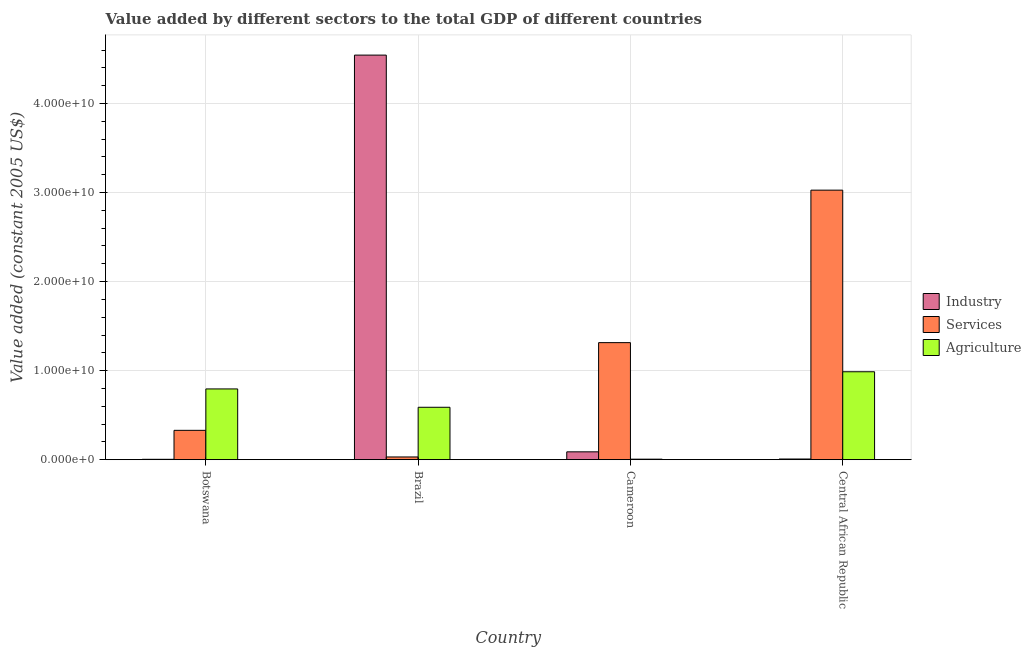Are the number of bars per tick equal to the number of legend labels?
Your response must be concise. Yes. Are the number of bars on each tick of the X-axis equal?
Provide a succinct answer. Yes. How many bars are there on the 2nd tick from the right?
Offer a terse response. 3. In how many cases, is the number of bars for a given country not equal to the number of legend labels?
Your answer should be very brief. 0. What is the value added by agricultural sector in Central African Republic?
Offer a terse response. 9.88e+09. Across all countries, what is the maximum value added by services?
Keep it short and to the point. 3.03e+1. Across all countries, what is the minimum value added by agricultural sector?
Ensure brevity in your answer.  5.92e+07. In which country was the value added by industrial sector maximum?
Make the answer very short. Brazil. In which country was the value added by industrial sector minimum?
Your answer should be compact. Botswana. What is the total value added by industrial sector in the graph?
Offer a very short reply. 4.64e+1. What is the difference between the value added by industrial sector in Botswana and that in Brazil?
Give a very brief answer. -4.54e+1. What is the difference between the value added by agricultural sector in Brazil and the value added by services in Cameroon?
Your answer should be very brief. -7.26e+09. What is the average value added by services per country?
Provide a succinct answer. 1.18e+1. What is the difference between the value added by services and value added by agricultural sector in Brazil?
Your response must be concise. -5.58e+09. What is the ratio of the value added by agricultural sector in Botswana to that in Central African Republic?
Offer a terse response. 0.8. Is the difference between the value added by industrial sector in Botswana and Brazil greater than the difference between the value added by agricultural sector in Botswana and Brazil?
Provide a short and direct response. No. What is the difference between the highest and the second highest value added by industrial sector?
Your answer should be compact. 4.46e+1. What is the difference between the highest and the lowest value added by industrial sector?
Keep it short and to the point. 4.54e+1. In how many countries, is the value added by agricultural sector greater than the average value added by agricultural sector taken over all countries?
Your response must be concise. 2. What does the 2nd bar from the left in Botswana represents?
Make the answer very short. Services. What does the 3rd bar from the right in Cameroon represents?
Offer a very short reply. Industry. Are all the bars in the graph horizontal?
Your response must be concise. No. Does the graph contain any zero values?
Offer a terse response. No. Does the graph contain grids?
Keep it short and to the point. Yes. Where does the legend appear in the graph?
Your response must be concise. Center right. How many legend labels are there?
Provide a short and direct response. 3. How are the legend labels stacked?
Provide a succinct answer. Vertical. What is the title of the graph?
Your answer should be compact. Value added by different sectors to the total GDP of different countries. Does "Profit Tax" appear as one of the legend labels in the graph?
Ensure brevity in your answer.  No. What is the label or title of the Y-axis?
Give a very brief answer. Value added (constant 2005 US$). What is the Value added (constant 2005 US$) of Industry in Botswana?
Your answer should be very brief. 4.36e+07. What is the Value added (constant 2005 US$) of Services in Botswana?
Your answer should be compact. 3.30e+09. What is the Value added (constant 2005 US$) in Agriculture in Botswana?
Ensure brevity in your answer.  7.95e+09. What is the Value added (constant 2005 US$) of Industry in Brazil?
Make the answer very short. 4.54e+1. What is the Value added (constant 2005 US$) of Services in Brazil?
Ensure brevity in your answer.  3.07e+08. What is the Value added (constant 2005 US$) in Agriculture in Brazil?
Keep it short and to the point. 5.89e+09. What is the Value added (constant 2005 US$) of Industry in Cameroon?
Keep it short and to the point. 8.83e+08. What is the Value added (constant 2005 US$) in Services in Cameroon?
Keep it short and to the point. 1.31e+1. What is the Value added (constant 2005 US$) of Agriculture in Cameroon?
Keep it short and to the point. 5.92e+07. What is the Value added (constant 2005 US$) of Industry in Central African Republic?
Provide a succinct answer. 7.69e+07. What is the Value added (constant 2005 US$) in Services in Central African Republic?
Your answer should be compact. 3.03e+1. What is the Value added (constant 2005 US$) of Agriculture in Central African Republic?
Offer a very short reply. 9.88e+09. Across all countries, what is the maximum Value added (constant 2005 US$) in Industry?
Keep it short and to the point. 4.54e+1. Across all countries, what is the maximum Value added (constant 2005 US$) of Services?
Provide a succinct answer. 3.03e+1. Across all countries, what is the maximum Value added (constant 2005 US$) in Agriculture?
Offer a very short reply. 9.88e+09. Across all countries, what is the minimum Value added (constant 2005 US$) of Industry?
Make the answer very short. 4.36e+07. Across all countries, what is the minimum Value added (constant 2005 US$) in Services?
Your answer should be compact. 3.07e+08. Across all countries, what is the minimum Value added (constant 2005 US$) in Agriculture?
Your answer should be very brief. 5.92e+07. What is the total Value added (constant 2005 US$) in Industry in the graph?
Provide a succinct answer. 4.64e+1. What is the total Value added (constant 2005 US$) in Services in the graph?
Offer a terse response. 4.70e+1. What is the total Value added (constant 2005 US$) of Agriculture in the graph?
Your response must be concise. 2.38e+1. What is the difference between the Value added (constant 2005 US$) of Industry in Botswana and that in Brazil?
Make the answer very short. -4.54e+1. What is the difference between the Value added (constant 2005 US$) in Services in Botswana and that in Brazil?
Provide a succinct answer. 2.99e+09. What is the difference between the Value added (constant 2005 US$) in Agriculture in Botswana and that in Brazil?
Your answer should be very brief. 2.06e+09. What is the difference between the Value added (constant 2005 US$) of Industry in Botswana and that in Cameroon?
Provide a succinct answer. -8.39e+08. What is the difference between the Value added (constant 2005 US$) of Services in Botswana and that in Cameroon?
Make the answer very short. -9.85e+09. What is the difference between the Value added (constant 2005 US$) of Agriculture in Botswana and that in Cameroon?
Offer a very short reply. 7.89e+09. What is the difference between the Value added (constant 2005 US$) in Industry in Botswana and that in Central African Republic?
Provide a succinct answer. -3.33e+07. What is the difference between the Value added (constant 2005 US$) of Services in Botswana and that in Central African Republic?
Your answer should be compact. -2.70e+1. What is the difference between the Value added (constant 2005 US$) of Agriculture in Botswana and that in Central African Republic?
Offer a very short reply. -1.93e+09. What is the difference between the Value added (constant 2005 US$) in Industry in Brazil and that in Cameroon?
Offer a terse response. 4.46e+1. What is the difference between the Value added (constant 2005 US$) in Services in Brazil and that in Cameroon?
Give a very brief answer. -1.28e+1. What is the difference between the Value added (constant 2005 US$) in Agriculture in Brazil and that in Cameroon?
Your response must be concise. 5.83e+09. What is the difference between the Value added (constant 2005 US$) in Industry in Brazil and that in Central African Republic?
Your response must be concise. 4.54e+1. What is the difference between the Value added (constant 2005 US$) in Services in Brazil and that in Central African Republic?
Keep it short and to the point. -3.00e+1. What is the difference between the Value added (constant 2005 US$) of Agriculture in Brazil and that in Central African Republic?
Your answer should be compact. -3.99e+09. What is the difference between the Value added (constant 2005 US$) in Industry in Cameroon and that in Central African Republic?
Give a very brief answer. 8.06e+08. What is the difference between the Value added (constant 2005 US$) in Services in Cameroon and that in Central African Republic?
Provide a succinct answer. -1.71e+1. What is the difference between the Value added (constant 2005 US$) in Agriculture in Cameroon and that in Central African Republic?
Provide a short and direct response. -9.82e+09. What is the difference between the Value added (constant 2005 US$) of Industry in Botswana and the Value added (constant 2005 US$) of Services in Brazil?
Your answer should be very brief. -2.63e+08. What is the difference between the Value added (constant 2005 US$) of Industry in Botswana and the Value added (constant 2005 US$) of Agriculture in Brazil?
Provide a short and direct response. -5.84e+09. What is the difference between the Value added (constant 2005 US$) of Services in Botswana and the Value added (constant 2005 US$) of Agriculture in Brazil?
Your answer should be very brief. -2.59e+09. What is the difference between the Value added (constant 2005 US$) of Industry in Botswana and the Value added (constant 2005 US$) of Services in Cameroon?
Keep it short and to the point. -1.31e+1. What is the difference between the Value added (constant 2005 US$) of Industry in Botswana and the Value added (constant 2005 US$) of Agriculture in Cameroon?
Ensure brevity in your answer.  -1.55e+07. What is the difference between the Value added (constant 2005 US$) in Services in Botswana and the Value added (constant 2005 US$) in Agriculture in Cameroon?
Provide a short and direct response. 3.24e+09. What is the difference between the Value added (constant 2005 US$) in Industry in Botswana and the Value added (constant 2005 US$) in Services in Central African Republic?
Keep it short and to the point. -3.02e+1. What is the difference between the Value added (constant 2005 US$) in Industry in Botswana and the Value added (constant 2005 US$) in Agriculture in Central African Republic?
Offer a terse response. -9.83e+09. What is the difference between the Value added (constant 2005 US$) in Services in Botswana and the Value added (constant 2005 US$) in Agriculture in Central African Republic?
Give a very brief answer. -6.58e+09. What is the difference between the Value added (constant 2005 US$) of Industry in Brazil and the Value added (constant 2005 US$) of Services in Cameroon?
Provide a succinct answer. 3.23e+1. What is the difference between the Value added (constant 2005 US$) of Industry in Brazil and the Value added (constant 2005 US$) of Agriculture in Cameroon?
Your answer should be very brief. 4.54e+1. What is the difference between the Value added (constant 2005 US$) in Services in Brazil and the Value added (constant 2005 US$) in Agriculture in Cameroon?
Keep it short and to the point. 2.48e+08. What is the difference between the Value added (constant 2005 US$) of Industry in Brazil and the Value added (constant 2005 US$) of Services in Central African Republic?
Ensure brevity in your answer.  1.52e+1. What is the difference between the Value added (constant 2005 US$) of Industry in Brazil and the Value added (constant 2005 US$) of Agriculture in Central African Republic?
Offer a very short reply. 3.56e+1. What is the difference between the Value added (constant 2005 US$) in Services in Brazil and the Value added (constant 2005 US$) in Agriculture in Central African Republic?
Your response must be concise. -9.57e+09. What is the difference between the Value added (constant 2005 US$) in Industry in Cameroon and the Value added (constant 2005 US$) in Services in Central African Republic?
Give a very brief answer. -2.94e+1. What is the difference between the Value added (constant 2005 US$) in Industry in Cameroon and the Value added (constant 2005 US$) in Agriculture in Central African Republic?
Make the answer very short. -8.99e+09. What is the difference between the Value added (constant 2005 US$) of Services in Cameroon and the Value added (constant 2005 US$) of Agriculture in Central African Republic?
Your response must be concise. 3.27e+09. What is the average Value added (constant 2005 US$) of Industry per country?
Your answer should be compact. 1.16e+1. What is the average Value added (constant 2005 US$) in Services per country?
Ensure brevity in your answer.  1.18e+1. What is the average Value added (constant 2005 US$) of Agriculture per country?
Provide a succinct answer. 5.94e+09. What is the difference between the Value added (constant 2005 US$) in Industry and Value added (constant 2005 US$) in Services in Botswana?
Provide a short and direct response. -3.25e+09. What is the difference between the Value added (constant 2005 US$) of Industry and Value added (constant 2005 US$) of Agriculture in Botswana?
Ensure brevity in your answer.  -7.90e+09. What is the difference between the Value added (constant 2005 US$) of Services and Value added (constant 2005 US$) of Agriculture in Botswana?
Ensure brevity in your answer.  -4.65e+09. What is the difference between the Value added (constant 2005 US$) in Industry and Value added (constant 2005 US$) in Services in Brazil?
Keep it short and to the point. 4.51e+1. What is the difference between the Value added (constant 2005 US$) of Industry and Value added (constant 2005 US$) of Agriculture in Brazil?
Give a very brief answer. 3.95e+1. What is the difference between the Value added (constant 2005 US$) in Services and Value added (constant 2005 US$) in Agriculture in Brazil?
Your response must be concise. -5.58e+09. What is the difference between the Value added (constant 2005 US$) in Industry and Value added (constant 2005 US$) in Services in Cameroon?
Provide a short and direct response. -1.23e+1. What is the difference between the Value added (constant 2005 US$) of Industry and Value added (constant 2005 US$) of Agriculture in Cameroon?
Ensure brevity in your answer.  8.24e+08. What is the difference between the Value added (constant 2005 US$) of Services and Value added (constant 2005 US$) of Agriculture in Cameroon?
Make the answer very short. 1.31e+1. What is the difference between the Value added (constant 2005 US$) of Industry and Value added (constant 2005 US$) of Services in Central African Republic?
Your response must be concise. -3.02e+1. What is the difference between the Value added (constant 2005 US$) of Industry and Value added (constant 2005 US$) of Agriculture in Central African Republic?
Keep it short and to the point. -9.80e+09. What is the difference between the Value added (constant 2005 US$) of Services and Value added (constant 2005 US$) of Agriculture in Central African Republic?
Give a very brief answer. 2.04e+1. What is the ratio of the Value added (constant 2005 US$) in Industry in Botswana to that in Brazil?
Keep it short and to the point. 0. What is the ratio of the Value added (constant 2005 US$) of Services in Botswana to that in Brazil?
Offer a very short reply. 10.74. What is the ratio of the Value added (constant 2005 US$) of Agriculture in Botswana to that in Brazil?
Offer a very short reply. 1.35. What is the ratio of the Value added (constant 2005 US$) in Industry in Botswana to that in Cameroon?
Offer a terse response. 0.05. What is the ratio of the Value added (constant 2005 US$) of Services in Botswana to that in Cameroon?
Offer a terse response. 0.25. What is the ratio of the Value added (constant 2005 US$) of Agriculture in Botswana to that in Cameroon?
Make the answer very short. 134.3. What is the ratio of the Value added (constant 2005 US$) in Industry in Botswana to that in Central African Republic?
Offer a very short reply. 0.57. What is the ratio of the Value added (constant 2005 US$) in Services in Botswana to that in Central African Republic?
Ensure brevity in your answer.  0.11. What is the ratio of the Value added (constant 2005 US$) in Agriculture in Botswana to that in Central African Republic?
Provide a succinct answer. 0.8. What is the ratio of the Value added (constant 2005 US$) in Industry in Brazil to that in Cameroon?
Offer a very short reply. 51.45. What is the ratio of the Value added (constant 2005 US$) of Services in Brazil to that in Cameroon?
Offer a terse response. 0.02. What is the ratio of the Value added (constant 2005 US$) of Agriculture in Brazil to that in Cameroon?
Offer a very short reply. 99.49. What is the ratio of the Value added (constant 2005 US$) in Industry in Brazil to that in Central African Republic?
Provide a succinct answer. 590.62. What is the ratio of the Value added (constant 2005 US$) in Services in Brazil to that in Central African Republic?
Give a very brief answer. 0.01. What is the ratio of the Value added (constant 2005 US$) in Agriculture in Brazil to that in Central African Republic?
Offer a very short reply. 0.6. What is the ratio of the Value added (constant 2005 US$) in Industry in Cameroon to that in Central African Republic?
Make the answer very short. 11.48. What is the ratio of the Value added (constant 2005 US$) of Services in Cameroon to that in Central African Republic?
Keep it short and to the point. 0.43. What is the ratio of the Value added (constant 2005 US$) of Agriculture in Cameroon to that in Central African Republic?
Make the answer very short. 0.01. What is the difference between the highest and the second highest Value added (constant 2005 US$) in Industry?
Offer a very short reply. 4.46e+1. What is the difference between the highest and the second highest Value added (constant 2005 US$) of Services?
Your answer should be compact. 1.71e+1. What is the difference between the highest and the second highest Value added (constant 2005 US$) in Agriculture?
Provide a succinct answer. 1.93e+09. What is the difference between the highest and the lowest Value added (constant 2005 US$) in Industry?
Offer a terse response. 4.54e+1. What is the difference between the highest and the lowest Value added (constant 2005 US$) in Services?
Offer a very short reply. 3.00e+1. What is the difference between the highest and the lowest Value added (constant 2005 US$) in Agriculture?
Your answer should be compact. 9.82e+09. 